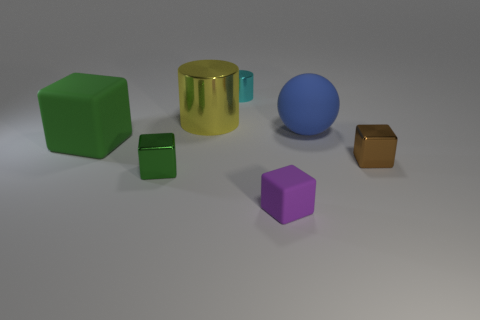Subtract 1 cubes. How many cubes are left? 3 Add 3 big blue things. How many objects exist? 10 Subtract all cubes. How many objects are left? 3 Subtract 0 cyan cubes. How many objects are left? 7 Subtract all metallic blocks. Subtract all yellow metal cylinders. How many objects are left? 4 Add 4 large rubber blocks. How many large rubber blocks are left? 5 Add 4 large rubber balls. How many large rubber balls exist? 5 